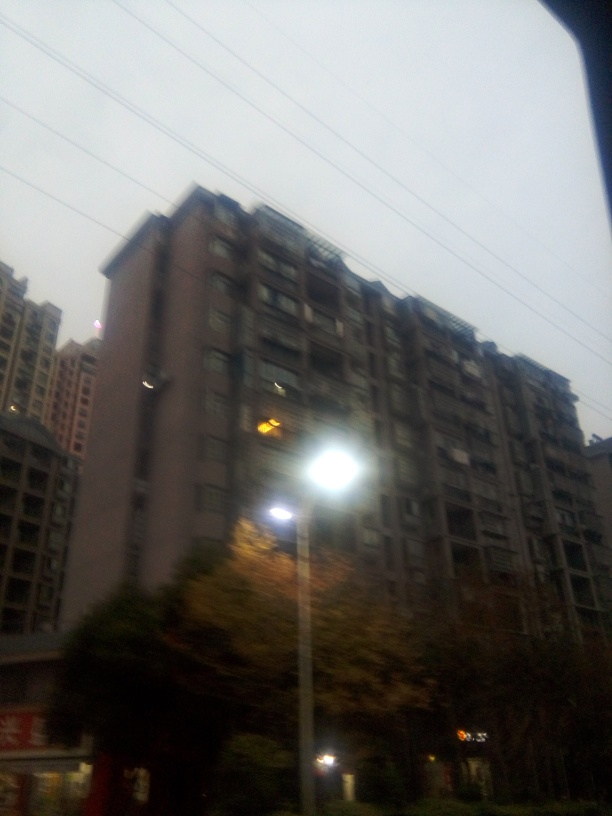What mood does the lighting in this image convey, and how does it affect the perception of the building? The image emanates a somber or gloomy mood due to the dimly lit surroundings and the building's austere appearance. The street lamp's strong glow in the foreground adds a contrasting brightness, highlighting the textural details of the nearby tree and deepening shadows elsewhere, which can make the building seem more imposing and melancholic. If you had to imagine a story about the single lit window in the building, what would it be? The solitary lit window could hint at a lone individual working late into the evening, possibly a writer seeking solitude to meet a deadline or an artist finding inspiration in the night's quiet. It's a small beacon of activity in an otherwise still and silent facade, suggesting an intimate narrative amidst the anonymity of the high-rise. 